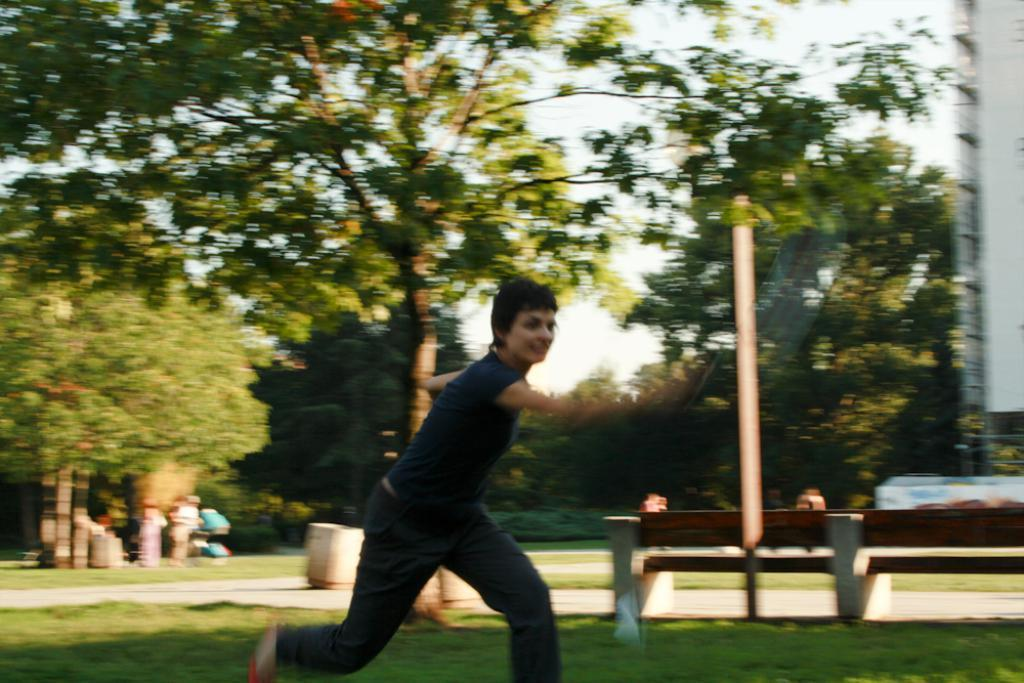What is the person in the image doing? There is a person running in the image. What type of natural elements can be seen in the image? There are trees in the image. What type of structure is present in the image? There is a bench and a building on the right side of the image. How many people are visible in the image? There are people standing in the image. What is visible in the sky in the image? The sky is visible in the image. What type of territory does the person running claim in the image? There is no indication in the image that the person is claiming any territory. Can you see any wings on the person running in the image? There are no wings visible on the person running in the image. 